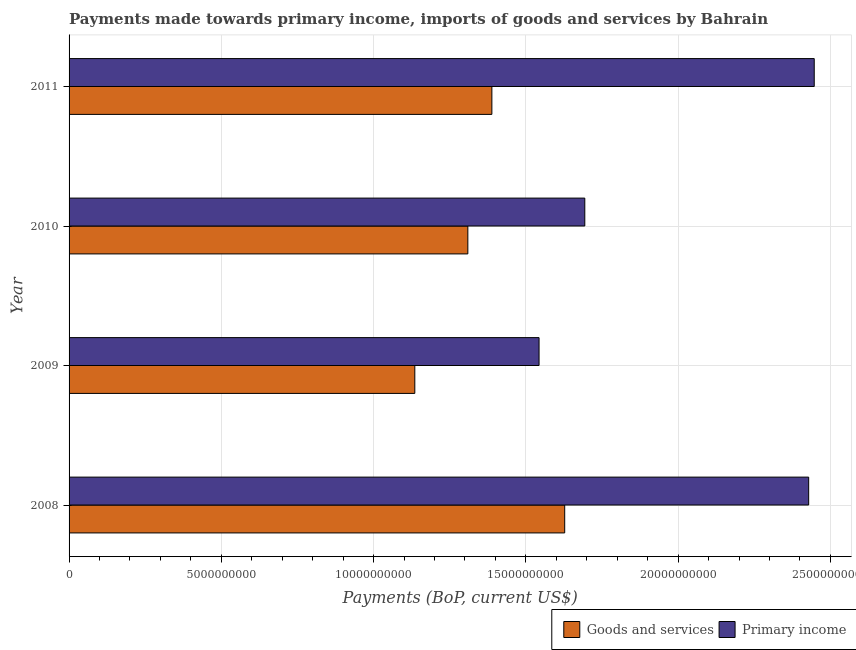How many different coloured bars are there?
Your answer should be compact. 2. How many bars are there on the 4th tick from the bottom?
Ensure brevity in your answer.  2. In how many cases, is the number of bars for a given year not equal to the number of legend labels?
Your answer should be compact. 0. What is the payments made towards primary income in 2008?
Provide a short and direct response. 2.43e+1. Across all years, what is the maximum payments made towards primary income?
Your response must be concise. 2.45e+1. Across all years, what is the minimum payments made towards goods and services?
Your answer should be very brief. 1.14e+1. In which year was the payments made towards primary income maximum?
Give a very brief answer. 2011. What is the total payments made towards goods and services in the graph?
Your answer should be very brief. 5.46e+1. What is the difference between the payments made towards goods and services in 2010 and that in 2011?
Give a very brief answer. -7.89e+08. What is the difference between the payments made towards primary income in 2010 and the payments made towards goods and services in 2008?
Your answer should be very brief. 6.60e+08. What is the average payments made towards primary income per year?
Offer a very short reply. 2.03e+1. In the year 2010, what is the difference between the payments made towards primary income and payments made towards goods and services?
Make the answer very short. 3.84e+09. What is the ratio of the payments made towards goods and services in 2010 to that in 2011?
Your answer should be very brief. 0.94. Is the payments made towards goods and services in 2008 less than that in 2011?
Offer a very short reply. No. Is the difference between the payments made towards goods and services in 2008 and 2010 greater than the difference between the payments made towards primary income in 2008 and 2010?
Offer a terse response. No. What is the difference between the highest and the second highest payments made towards goods and services?
Offer a terse response. 2.39e+09. What is the difference between the highest and the lowest payments made towards goods and services?
Ensure brevity in your answer.  4.92e+09. In how many years, is the payments made towards primary income greater than the average payments made towards primary income taken over all years?
Your answer should be compact. 2. Is the sum of the payments made towards goods and services in 2009 and 2010 greater than the maximum payments made towards primary income across all years?
Make the answer very short. No. What does the 2nd bar from the top in 2008 represents?
Your response must be concise. Goods and services. What does the 2nd bar from the bottom in 2008 represents?
Keep it short and to the point. Primary income. How many bars are there?
Provide a short and direct response. 8. Does the graph contain any zero values?
Offer a terse response. No. Does the graph contain grids?
Offer a very short reply. Yes. How are the legend labels stacked?
Provide a succinct answer. Horizontal. What is the title of the graph?
Your answer should be very brief. Payments made towards primary income, imports of goods and services by Bahrain. Does "Broad money growth" appear as one of the legend labels in the graph?
Provide a short and direct response. No. What is the label or title of the X-axis?
Make the answer very short. Payments (BoP, current US$). What is the Payments (BoP, current US$) in Goods and services in 2008?
Keep it short and to the point. 1.63e+1. What is the Payments (BoP, current US$) of Primary income in 2008?
Ensure brevity in your answer.  2.43e+1. What is the Payments (BoP, current US$) in Goods and services in 2009?
Your answer should be very brief. 1.14e+1. What is the Payments (BoP, current US$) of Primary income in 2009?
Your answer should be very brief. 1.54e+1. What is the Payments (BoP, current US$) of Goods and services in 2010?
Give a very brief answer. 1.31e+1. What is the Payments (BoP, current US$) in Primary income in 2010?
Offer a very short reply. 1.69e+1. What is the Payments (BoP, current US$) in Goods and services in 2011?
Offer a terse response. 1.39e+1. What is the Payments (BoP, current US$) in Primary income in 2011?
Your answer should be very brief. 2.45e+1. Across all years, what is the maximum Payments (BoP, current US$) in Goods and services?
Provide a short and direct response. 1.63e+1. Across all years, what is the maximum Payments (BoP, current US$) in Primary income?
Offer a very short reply. 2.45e+1. Across all years, what is the minimum Payments (BoP, current US$) of Goods and services?
Keep it short and to the point. 1.14e+1. Across all years, what is the minimum Payments (BoP, current US$) in Primary income?
Provide a short and direct response. 1.54e+1. What is the total Payments (BoP, current US$) of Goods and services in the graph?
Offer a very short reply. 5.46e+1. What is the total Payments (BoP, current US$) of Primary income in the graph?
Provide a short and direct response. 8.11e+1. What is the difference between the Payments (BoP, current US$) of Goods and services in 2008 and that in 2009?
Provide a succinct answer. 4.92e+09. What is the difference between the Payments (BoP, current US$) of Primary income in 2008 and that in 2009?
Offer a terse response. 8.85e+09. What is the difference between the Payments (BoP, current US$) of Goods and services in 2008 and that in 2010?
Your answer should be compact. 3.18e+09. What is the difference between the Payments (BoP, current US$) of Primary income in 2008 and that in 2010?
Your response must be concise. 7.35e+09. What is the difference between the Payments (BoP, current US$) in Goods and services in 2008 and that in 2011?
Make the answer very short. 2.39e+09. What is the difference between the Payments (BoP, current US$) in Primary income in 2008 and that in 2011?
Provide a succinct answer. -1.82e+08. What is the difference between the Payments (BoP, current US$) in Goods and services in 2009 and that in 2010?
Provide a succinct answer. -1.74e+09. What is the difference between the Payments (BoP, current US$) in Primary income in 2009 and that in 2010?
Ensure brevity in your answer.  -1.50e+09. What is the difference between the Payments (BoP, current US$) of Goods and services in 2009 and that in 2011?
Keep it short and to the point. -2.53e+09. What is the difference between the Payments (BoP, current US$) in Primary income in 2009 and that in 2011?
Provide a succinct answer. -9.04e+09. What is the difference between the Payments (BoP, current US$) of Goods and services in 2010 and that in 2011?
Your answer should be very brief. -7.89e+08. What is the difference between the Payments (BoP, current US$) of Primary income in 2010 and that in 2011?
Your response must be concise. -7.53e+09. What is the difference between the Payments (BoP, current US$) of Goods and services in 2008 and the Payments (BoP, current US$) of Primary income in 2009?
Your answer should be compact. 8.42e+08. What is the difference between the Payments (BoP, current US$) in Goods and services in 2008 and the Payments (BoP, current US$) in Primary income in 2010?
Offer a terse response. -6.60e+08. What is the difference between the Payments (BoP, current US$) in Goods and services in 2008 and the Payments (BoP, current US$) in Primary income in 2011?
Give a very brief answer. -8.19e+09. What is the difference between the Payments (BoP, current US$) in Goods and services in 2009 and the Payments (BoP, current US$) in Primary income in 2010?
Provide a succinct answer. -5.58e+09. What is the difference between the Payments (BoP, current US$) in Goods and services in 2009 and the Payments (BoP, current US$) in Primary income in 2011?
Make the answer very short. -1.31e+1. What is the difference between the Payments (BoP, current US$) in Goods and services in 2010 and the Payments (BoP, current US$) in Primary income in 2011?
Offer a terse response. -1.14e+1. What is the average Payments (BoP, current US$) in Goods and services per year?
Your answer should be compact. 1.37e+1. What is the average Payments (BoP, current US$) in Primary income per year?
Make the answer very short. 2.03e+1. In the year 2008, what is the difference between the Payments (BoP, current US$) of Goods and services and Payments (BoP, current US$) of Primary income?
Make the answer very short. -8.01e+09. In the year 2009, what is the difference between the Payments (BoP, current US$) in Goods and services and Payments (BoP, current US$) in Primary income?
Your answer should be very brief. -4.08e+09. In the year 2010, what is the difference between the Payments (BoP, current US$) in Goods and services and Payments (BoP, current US$) in Primary income?
Offer a very short reply. -3.84e+09. In the year 2011, what is the difference between the Payments (BoP, current US$) of Goods and services and Payments (BoP, current US$) of Primary income?
Your answer should be compact. -1.06e+1. What is the ratio of the Payments (BoP, current US$) in Goods and services in 2008 to that in 2009?
Provide a succinct answer. 1.43. What is the ratio of the Payments (BoP, current US$) of Primary income in 2008 to that in 2009?
Provide a short and direct response. 1.57. What is the ratio of the Payments (BoP, current US$) of Goods and services in 2008 to that in 2010?
Your response must be concise. 1.24. What is the ratio of the Payments (BoP, current US$) of Primary income in 2008 to that in 2010?
Make the answer very short. 1.43. What is the ratio of the Payments (BoP, current US$) in Goods and services in 2008 to that in 2011?
Provide a short and direct response. 1.17. What is the ratio of the Payments (BoP, current US$) of Primary income in 2008 to that in 2011?
Offer a very short reply. 0.99. What is the ratio of the Payments (BoP, current US$) in Goods and services in 2009 to that in 2010?
Make the answer very short. 0.87. What is the ratio of the Payments (BoP, current US$) in Primary income in 2009 to that in 2010?
Offer a very short reply. 0.91. What is the ratio of the Payments (BoP, current US$) of Goods and services in 2009 to that in 2011?
Offer a terse response. 0.82. What is the ratio of the Payments (BoP, current US$) of Primary income in 2009 to that in 2011?
Your answer should be compact. 0.63. What is the ratio of the Payments (BoP, current US$) of Goods and services in 2010 to that in 2011?
Provide a short and direct response. 0.94. What is the ratio of the Payments (BoP, current US$) of Primary income in 2010 to that in 2011?
Offer a terse response. 0.69. What is the difference between the highest and the second highest Payments (BoP, current US$) of Goods and services?
Your answer should be compact. 2.39e+09. What is the difference between the highest and the second highest Payments (BoP, current US$) of Primary income?
Ensure brevity in your answer.  1.82e+08. What is the difference between the highest and the lowest Payments (BoP, current US$) of Goods and services?
Give a very brief answer. 4.92e+09. What is the difference between the highest and the lowest Payments (BoP, current US$) of Primary income?
Give a very brief answer. 9.04e+09. 